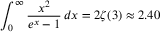<formula> <loc_0><loc_0><loc_500><loc_500>\int _ { 0 } ^ { \infty } { \frac { x ^ { 2 } } { e ^ { x } - 1 } } \, d x = 2 \zeta ( 3 ) \approx 2 . 4 0</formula> 